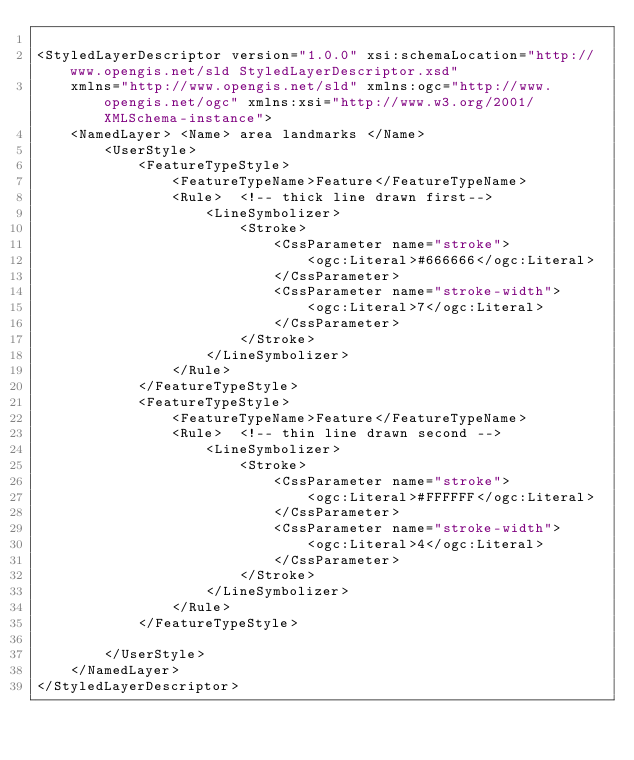<code> <loc_0><loc_0><loc_500><loc_500><_Scheme_>
<StyledLayerDescriptor version="1.0.0" xsi:schemaLocation="http://www.opengis.net/sld StyledLayerDescriptor.xsd"
    xmlns="http://www.opengis.net/sld" xmlns:ogc="http://www.opengis.net/ogc" xmlns:xsi="http://www.w3.org/2001/XMLSchema-instance">
    <NamedLayer> <Name> area landmarks </Name>
        <UserStyle>
            <FeatureTypeStyle>
                <FeatureTypeName>Feature</FeatureTypeName>
                <Rule>  <!-- thick line drawn first-->
                    <LineSymbolizer>
                        <Stroke>
                            <CssParameter name="stroke">
                                <ogc:Literal>#666666</ogc:Literal>
                            </CssParameter>
                            <CssParameter name="stroke-width">
                                <ogc:Literal>7</ogc:Literal>
                            </CssParameter>
                        </Stroke>
                    </LineSymbolizer>
                </Rule>
            </FeatureTypeStyle>
            <FeatureTypeStyle>
                <FeatureTypeName>Feature</FeatureTypeName>
                <Rule>  <!-- thin line drawn second -->
                    <LineSymbolizer>
                        <Stroke>
                            <CssParameter name="stroke">
                                <ogc:Literal>#FFFFFF</ogc:Literal>
                            </CssParameter>
                            <CssParameter name="stroke-width">
                                <ogc:Literal>4</ogc:Literal>
                            </CssParameter>
                        </Stroke>
                    </LineSymbolizer>
                </Rule>
            </FeatureTypeStyle>

        </UserStyle>
    </NamedLayer>
</StyledLayerDescriptor>
</code> 